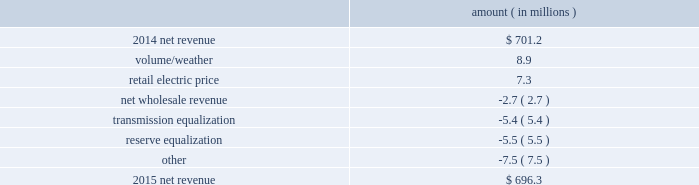Entergy mississippi , inc .
Management 2019s financial discussion and analysis the net wholesale revenue variance is primarily due to entergy mississippi 2019s exit from the system agreement in november 2015 .
The reserve equalization revenue variance is primarily due to the absence of reserve equalization revenue as compared to the same period in 2015 resulting from entergy mississippi 2019s exit from the system agreement in november 2015 compared to 2014 net revenue consists of operating revenues net of : 1 ) fuel , fuel-related expenses , and gas purchased for resale , 2 ) purchased power expenses , and 3 ) other regulatory charges .
Following is an analysis of the change in net revenue comparing 2015 to 2014 .
Amount ( in millions ) .
The volume/weather variance is primarily due to an increase of 86 gwh , or 1% ( 1 % ) , in billed electricity usage , including the effect of more favorable weather on residential and commercial sales .
The retail electric price variance is primarily due to a $ 16 million net annual increase in revenues , effective february 2015 , as a result of the mpsc order in the june 2014 rate case and an increase in revenues collected through the energy efficiency rider , partially offset by a decrease in revenues collected through the storm damage rider .
The rate case included the realignment of certain costs from collection in riders to base rates .
See note 2 to the financial statements for a discussion of the rate case , the energy efficiency rider , and the storm damage rider .
The net wholesale revenue variance is primarily due to a wholesale customer contract termination in october transmission equalization revenue represents amounts received by entergy mississippi from certain other entergy utility operating companies , in accordance with the system agreement , to allocate the costs of collectively planning , constructing , and operating entergy 2019s bulk transmission facilities .
The transmission equalization variance is primarily attributable to the realignment , effective february 2015 , of these revenues from the determination of base rates to inclusion in a rider .
Such revenues had a favorable effect on net revenue in 2014 , but minimal effect in 2015 .
Entergy mississippi exited the system agreement in november 2015 .
See note 2 to the financial statements for a discussion of the system agreement .
Reserve equalization revenue represents amounts received by entergy mississippi from certain other entergy utility operating companies , in accordance with the system agreement , to allocate the costs of collectively maintaining adequate electric generating capacity across the entergy system .
The reserve equalization variance is primarily attributable to the realignment , effective february 2015 , of these revenues from the determination of base rates to inclusion in a rider .
Such revenues had a favorable effect on net revenue in 2014 , but minimal effect in 2015 .
Entergy .
What is the net change in net revenue during 2015 for entergy mississippi , inc.? 
Computations: (696.3 - 701.2)
Answer: -4.9. Entergy mississippi , inc .
Management 2019s financial discussion and analysis the net wholesale revenue variance is primarily due to entergy mississippi 2019s exit from the system agreement in november 2015 .
The reserve equalization revenue variance is primarily due to the absence of reserve equalization revenue as compared to the same period in 2015 resulting from entergy mississippi 2019s exit from the system agreement in november 2015 compared to 2014 net revenue consists of operating revenues net of : 1 ) fuel , fuel-related expenses , and gas purchased for resale , 2 ) purchased power expenses , and 3 ) other regulatory charges .
Following is an analysis of the change in net revenue comparing 2015 to 2014 .
Amount ( in millions ) .
The volume/weather variance is primarily due to an increase of 86 gwh , or 1% ( 1 % ) , in billed electricity usage , including the effect of more favorable weather on residential and commercial sales .
The retail electric price variance is primarily due to a $ 16 million net annual increase in revenues , effective february 2015 , as a result of the mpsc order in the june 2014 rate case and an increase in revenues collected through the energy efficiency rider , partially offset by a decrease in revenues collected through the storm damage rider .
The rate case included the realignment of certain costs from collection in riders to base rates .
See note 2 to the financial statements for a discussion of the rate case , the energy efficiency rider , and the storm damage rider .
The net wholesale revenue variance is primarily due to a wholesale customer contract termination in october transmission equalization revenue represents amounts received by entergy mississippi from certain other entergy utility operating companies , in accordance with the system agreement , to allocate the costs of collectively planning , constructing , and operating entergy 2019s bulk transmission facilities .
The transmission equalization variance is primarily attributable to the realignment , effective february 2015 , of these revenues from the determination of base rates to inclusion in a rider .
Such revenues had a favorable effect on net revenue in 2014 , but minimal effect in 2015 .
Entergy mississippi exited the system agreement in november 2015 .
See note 2 to the financial statements for a discussion of the system agreement .
Reserve equalization revenue represents amounts received by entergy mississippi from certain other entergy utility operating companies , in accordance with the system agreement , to allocate the costs of collectively maintaining adequate electric generating capacity across the entergy system .
The reserve equalization variance is primarily attributable to the realignment , effective february 2015 , of these revenues from the determination of base rates to inclusion in a rider .
Such revenues had a favorable effect on net revenue in 2014 , but minimal effect in 2015 .
Entergy .
Did the volume/weather adjustment have a greater impact on 2015 net revenue than the retail electric price adjustment? 
Computations: (8.9 > 7.3)
Answer: yes. Entergy mississippi , inc .
Management 2019s financial discussion and analysis the net wholesale revenue variance is primarily due to entergy mississippi 2019s exit from the system agreement in november 2015 .
The reserve equalization revenue variance is primarily due to the absence of reserve equalization revenue as compared to the same period in 2015 resulting from entergy mississippi 2019s exit from the system agreement in november 2015 compared to 2014 net revenue consists of operating revenues net of : 1 ) fuel , fuel-related expenses , and gas purchased for resale , 2 ) purchased power expenses , and 3 ) other regulatory charges .
Following is an analysis of the change in net revenue comparing 2015 to 2014 .
Amount ( in millions ) .
The volume/weather variance is primarily due to an increase of 86 gwh , or 1% ( 1 % ) , in billed electricity usage , including the effect of more favorable weather on residential and commercial sales .
The retail electric price variance is primarily due to a $ 16 million net annual increase in revenues , effective february 2015 , as a result of the mpsc order in the june 2014 rate case and an increase in revenues collected through the energy efficiency rider , partially offset by a decrease in revenues collected through the storm damage rider .
The rate case included the realignment of certain costs from collection in riders to base rates .
See note 2 to the financial statements for a discussion of the rate case , the energy efficiency rider , and the storm damage rider .
The net wholesale revenue variance is primarily due to a wholesale customer contract termination in october transmission equalization revenue represents amounts received by entergy mississippi from certain other entergy utility operating companies , in accordance with the system agreement , to allocate the costs of collectively planning , constructing , and operating entergy 2019s bulk transmission facilities .
The transmission equalization variance is primarily attributable to the realignment , effective february 2015 , of these revenues from the determination of base rates to inclusion in a rider .
Such revenues had a favorable effect on net revenue in 2014 , but minimal effect in 2015 .
Entergy mississippi exited the system agreement in november 2015 .
See note 2 to the financial statements for a discussion of the system agreement .
Reserve equalization revenue represents amounts received by entergy mississippi from certain other entergy utility operating companies , in accordance with the system agreement , to allocate the costs of collectively maintaining adequate electric generating capacity across the entergy system .
The reserve equalization variance is primarily attributable to the realignment , effective february 2015 , of these revenues from the determination of base rates to inclusion in a rider .
Such revenues had a favorable effect on net revenue in 2014 , but minimal effect in 2015 .
Entergy .
How much cost would be passed on to customers over three years , in millions , due to the june 2014 rate case , the energy efficiency rider , and the storm damage rider? 
Computations: ((16 + 16) + 16)
Answer: 48.0. 